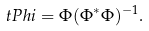<formula> <loc_0><loc_0><loc_500><loc_500>\ t P h i = \Phi ( \Phi ^ { * } \Phi ) ^ { - 1 } .</formula> 